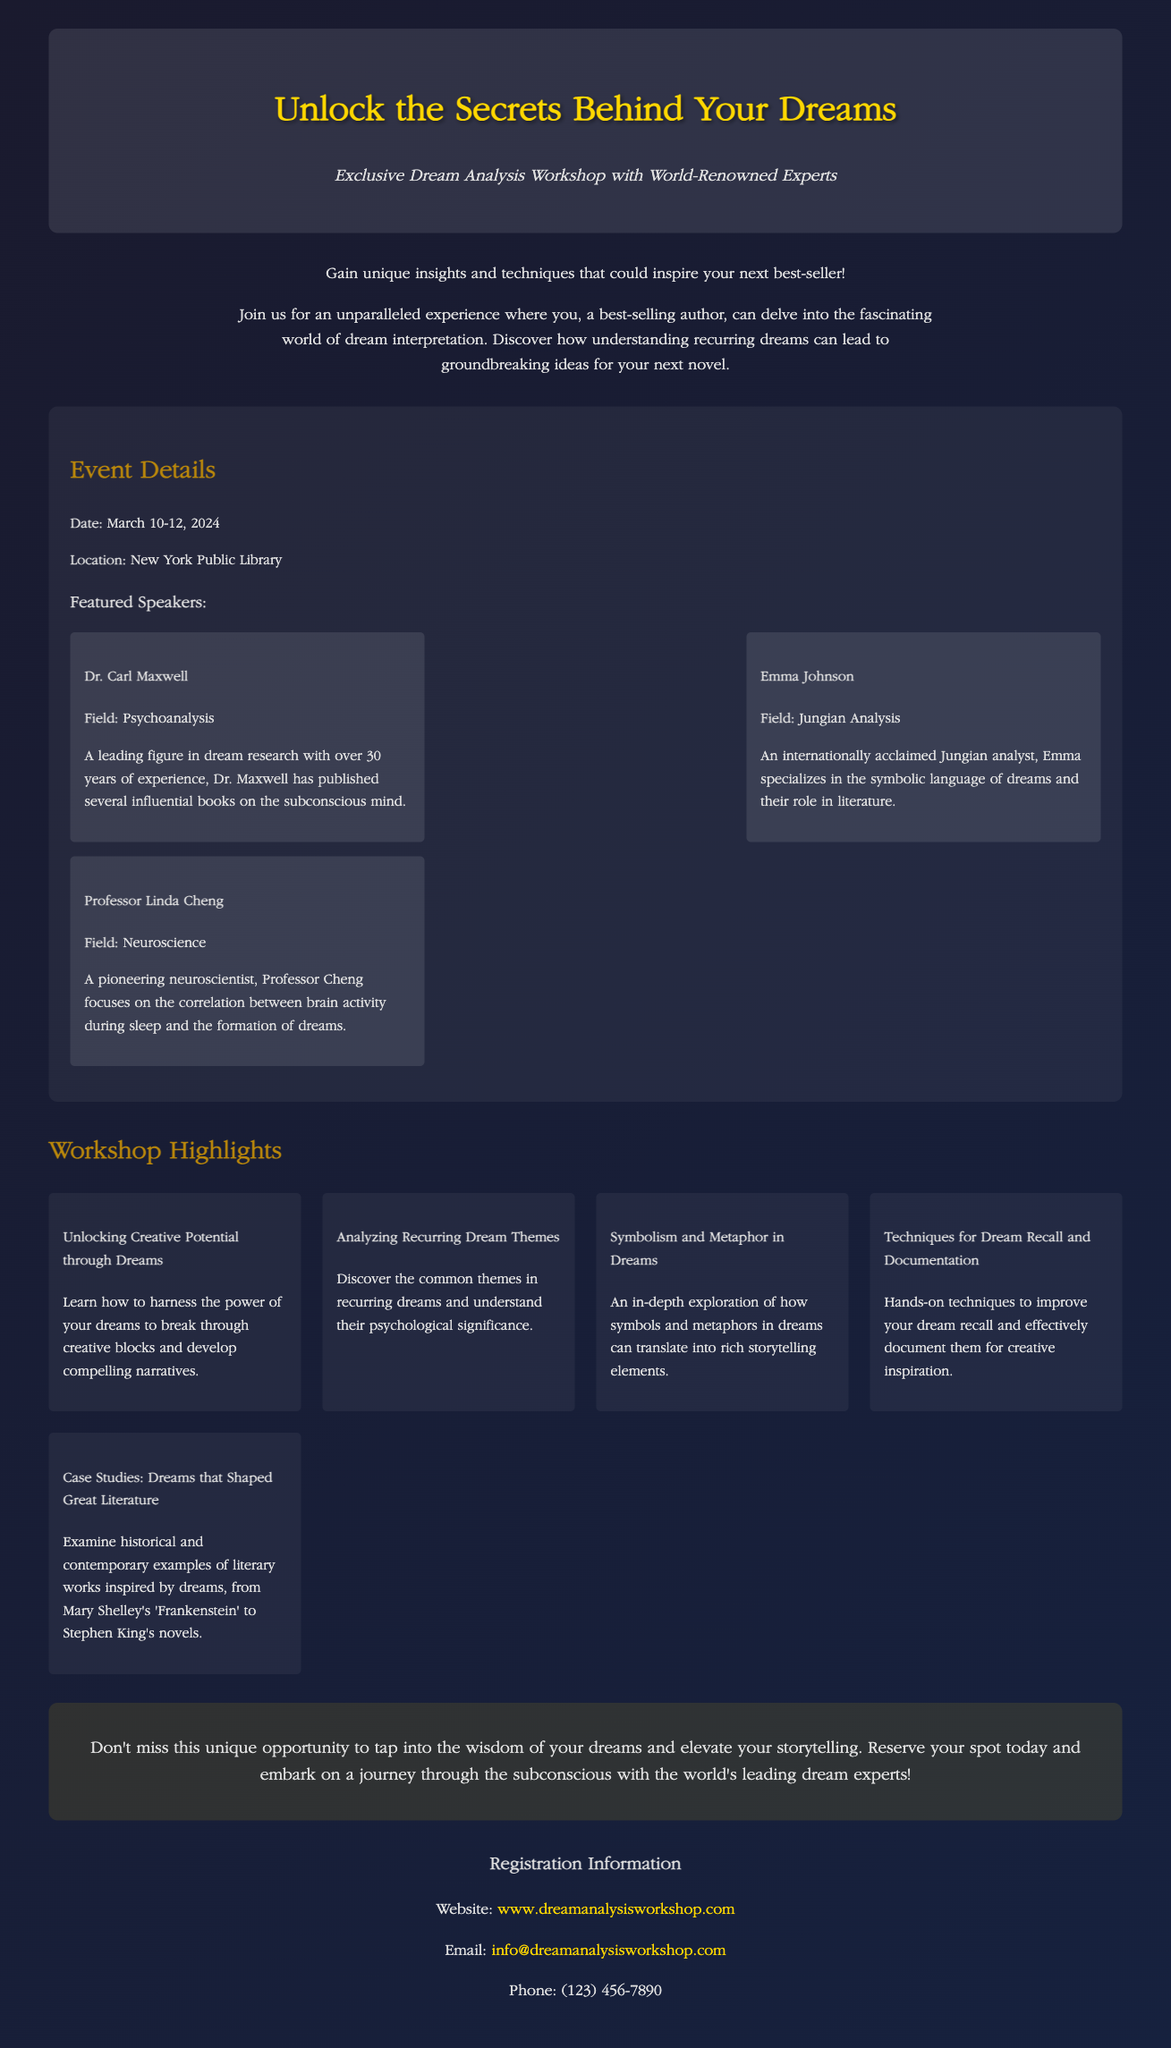What are the event dates? The event dates are explicitly mentioned in the document as March 10-12, 2024.
Answer: March 10-12, 2024 Who is Dr. Carl Maxwell? Dr. Carl Maxwell is one of the featured speakers, identified as a leading figure in dream research with over 30 years of experience.
Answer: Dr. Carl Maxwell What is the location of the workshop? The document specifies that the location of the workshop is the New York Public Library.
Answer: New York Public Library What is one highlight of the workshop? The document lists several highlights, including "Unlocking Creative Potential through Dreams."
Answer: Unlocking Creative Potential through Dreams What is the focus of Professor Linda Cheng's research? The document states that Professor Linda Cheng focuses on the correlation between brain activity during sleep and the formation of dreams.
Answer: Correlation between brain activity and dreams How many speakers are mentioned in the document? The document mentions three featured speakers in total for the workshop.
Answer: Three What is the email address for registration inquiries? The document provides the email address for registration as info@dreamanalysisworkshop.com.
Answer: info@dreamanalysisworkshop.com What is the workshop's primary theme? The document emphasizes that the workshop is centered around dream analysis and interpretation, aimed at authors seeking inspiration.
Answer: Dream analysis and interpretation What is the website for more information? The document lists the website for further details as www.dreamanalysisworkshop.com.
Answer: www.dreamanalysisworkshop.com 